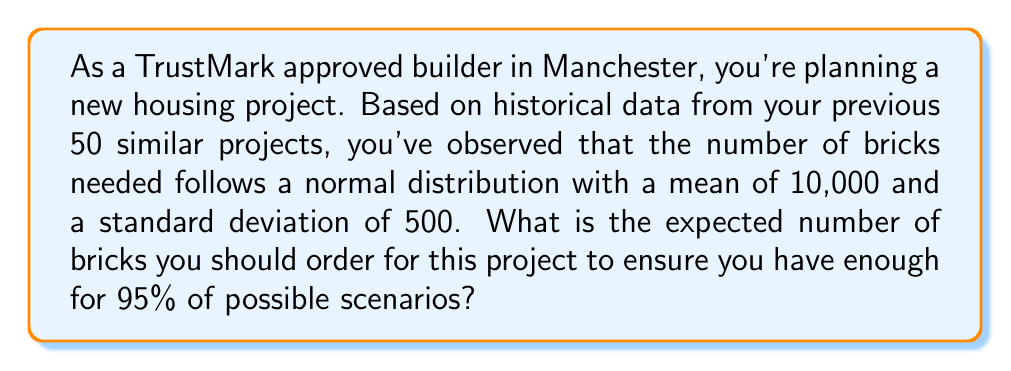Solve this math problem. To solve this problem, we need to use the properties of the normal distribution and the concept of z-scores.

1. Given information:
   - The number of bricks follows a normal distribution
   - Mean (μ) = 10,000 bricks
   - Standard deviation (σ) = 500 bricks
   - We want to cover 95% of possible scenarios

2. For a normal distribution, 95% of the data falls within 1.645 standard deviations above the mean. This corresponds to the 95th percentile.

3. We can calculate the number of bricks needed using the formula:
   $$ X = \mu + (z \times \sigma) $$
   Where:
   - X is the number of bricks we need to order
   - μ is the mean
   - z is the z-score for the 95th percentile (1.645)
   - σ is the standard deviation

4. Plugging in the values:
   $$ X = 10,000 + (1.645 \times 500) $$

5. Calculating:
   $$ X = 10,000 + 822.5 $$
   $$ X = 10,822.5 $$

6. Since we can't order a fractional number of bricks, we round up to the nearest whole number.
Answer: The expected number of bricks to order is 10,823. 